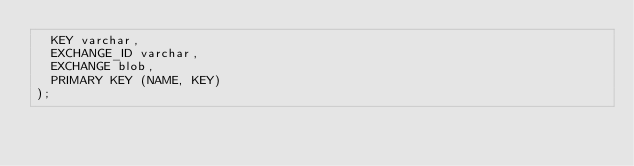Convert code to text. <code><loc_0><loc_0><loc_500><loc_500><_SQL_>  KEY varchar,
  EXCHANGE_ID varchar,
  EXCHANGE blob,
  PRIMARY KEY (NAME, KEY)
);
</code> 